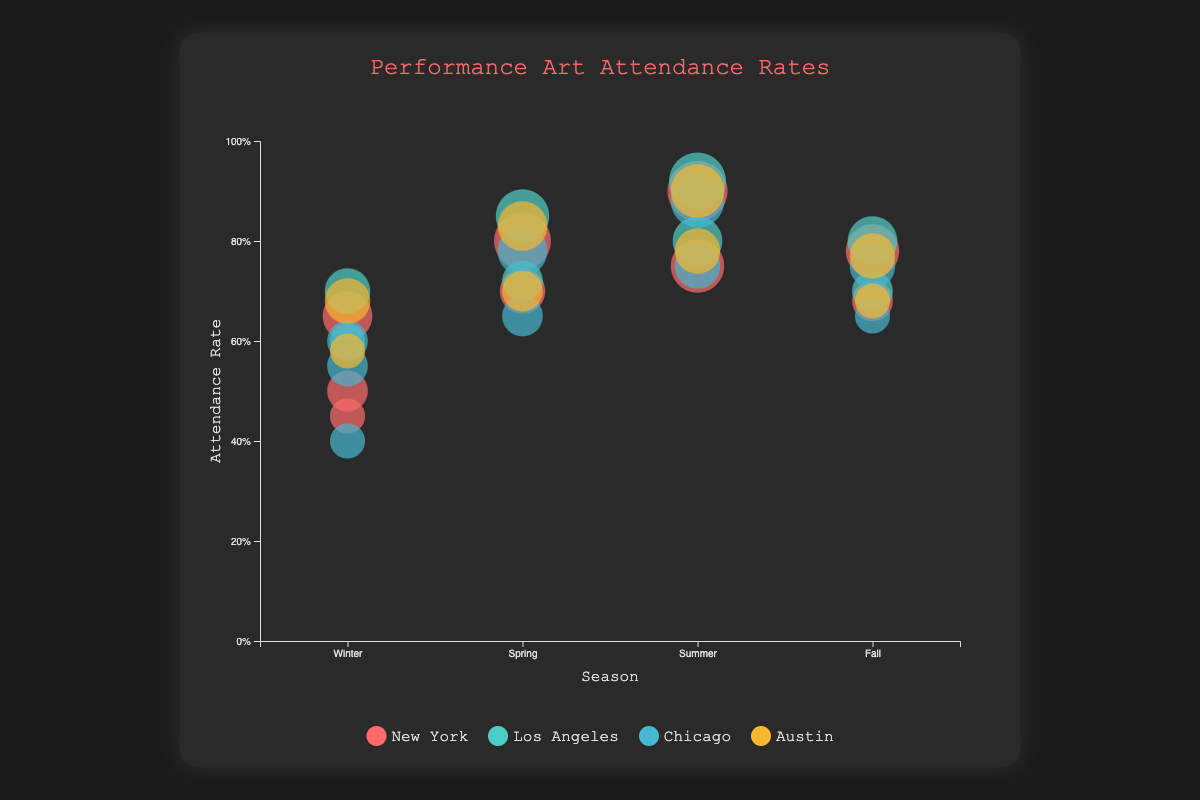What is the attendance rate for Clear weather in New York during the summer? In the bubble chart, locate the city "New York", then find the season "Summer". Within that season, look for "Clear" weather conditions and refer to its attendance rate.
Answer: 0.90 Which city has the highest attendance rate in the summer? Compare the attendance rates of all cities for the Summer season. Find the city with the highest value.
Answer: Los Angeles What is the range of attendance rates in Chicago for all seasons combined? Identify the lowest and highest attendance rates for Chicago across Winter, Spring, Summer, and Fall. The lowest is 0.40 in Winter (Snowy) and the highest is 0.88 in Summer (Clear).
Answer: 0.40 to 0.88 Which season in New York has the most consistent attendance rates regardless of weather conditions? Examine the attendance rates for each season in New York and determine which season has less variability between different weather conditions.
Answer: Spring How many performances were held in Los Angeles during the Winter for all weather conditions combined? Sum the performance counts of each weather condition (Clear and Rainy) in Los Angeles during Winter. Clear is 4 and Rainy is 2, so 4 + 2 = 6.
Answer: 6 How does the attendance rate for Clear weather in Chicago during Spring compare to Rainy weather in Austin during Summer? Compare the attendance rates: Spring with Clear weather in Chicago is 0.78, and Summer with Rainy weather in Austin is 0.78. Both values are the same.
Answer: Equal Which city and season had the lowest attendance rate overall? Identify the lowest single attendance rate across all cities and seasons. Chicago in Winter (Snowy) has the lowest at 0.40.
Answer: Chicago, Winter (Snowy) 